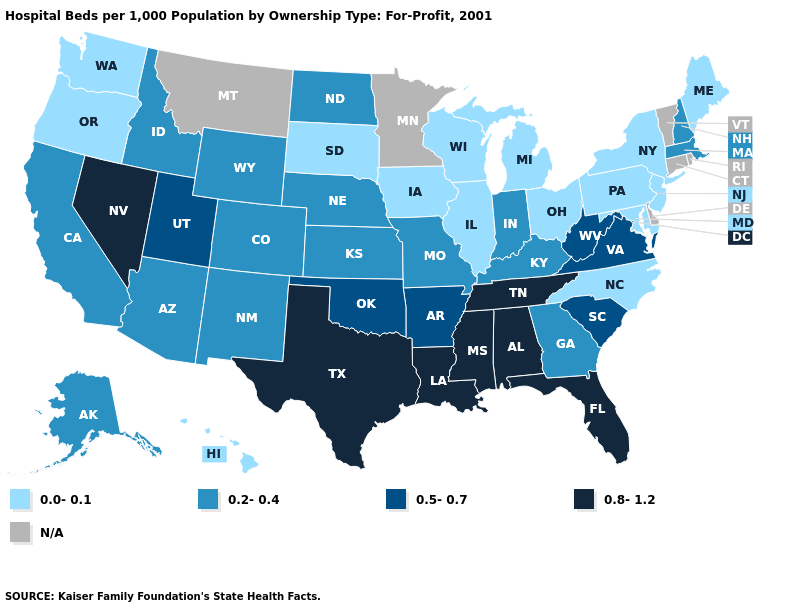What is the value of Arizona?
Give a very brief answer. 0.2-0.4. What is the value of Wyoming?
Answer briefly. 0.2-0.4. How many symbols are there in the legend?
Concise answer only. 5. Among the states that border Tennessee , does Alabama have the lowest value?
Write a very short answer. No. What is the value of Connecticut?
Write a very short answer. N/A. Name the states that have a value in the range 0.8-1.2?
Be succinct. Alabama, Florida, Louisiana, Mississippi, Nevada, Tennessee, Texas. Among the states that border Georgia , does Alabama have the highest value?
Concise answer only. Yes. Does Pennsylvania have the highest value in the Northeast?
Short answer required. No. Is the legend a continuous bar?
Short answer required. No. Does the map have missing data?
Keep it brief. Yes. Does Maryland have the lowest value in the South?
Short answer required. Yes. Name the states that have a value in the range 0.2-0.4?
Answer briefly. Alaska, Arizona, California, Colorado, Georgia, Idaho, Indiana, Kansas, Kentucky, Massachusetts, Missouri, Nebraska, New Hampshire, New Mexico, North Dakota, Wyoming. Name the states that have a value in the range 0.0-0.1?
Keep it brief. Hawaii, Illinois, Iowa, Maine, Maryland, Michigan, New Jersey, New York, North Carolina, Ohio, Oregon, Pennsylvania, South Dakota, Washington, Wisconsin. What is the highest value in the Northeast ?
Concise answer only. 0.2-0.4. 